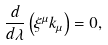<formula> <loc_0><loc_0><loc_500><loc_500>\frac { d } { d \lambda } \left ( \xi ^ { \mu } k _ { \mu } \right ) = 0 ,</formula> 